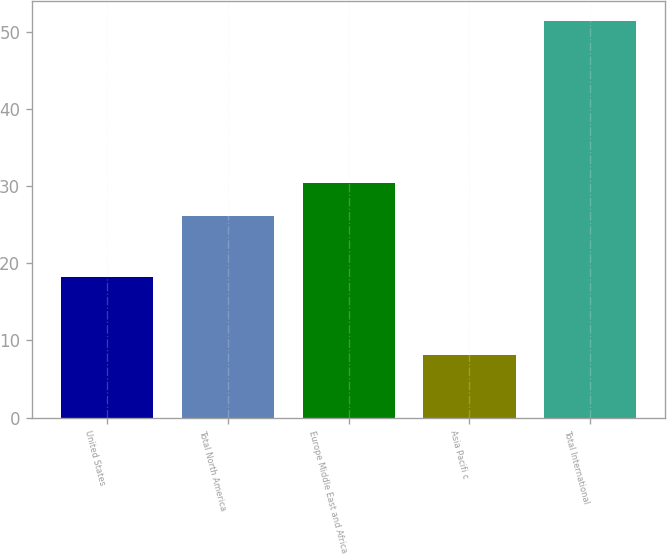<chart> <loc_0><loc_0><loc_500><loc_500><bar_chart><fcel>United States<fcel>Total North America<fcel>Europe Middle East and Africa<fcel>Asia Pacifi c<fcel>Total International<nl><fcel>18.2<fcel>26.1<fcel>30.43<fcel>8.1<fcel>51.4<nl></chart> 